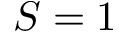Convert formula to latex. <formula><loc_0><loc_0><loc_500><loc_500>S = 1</formula> 